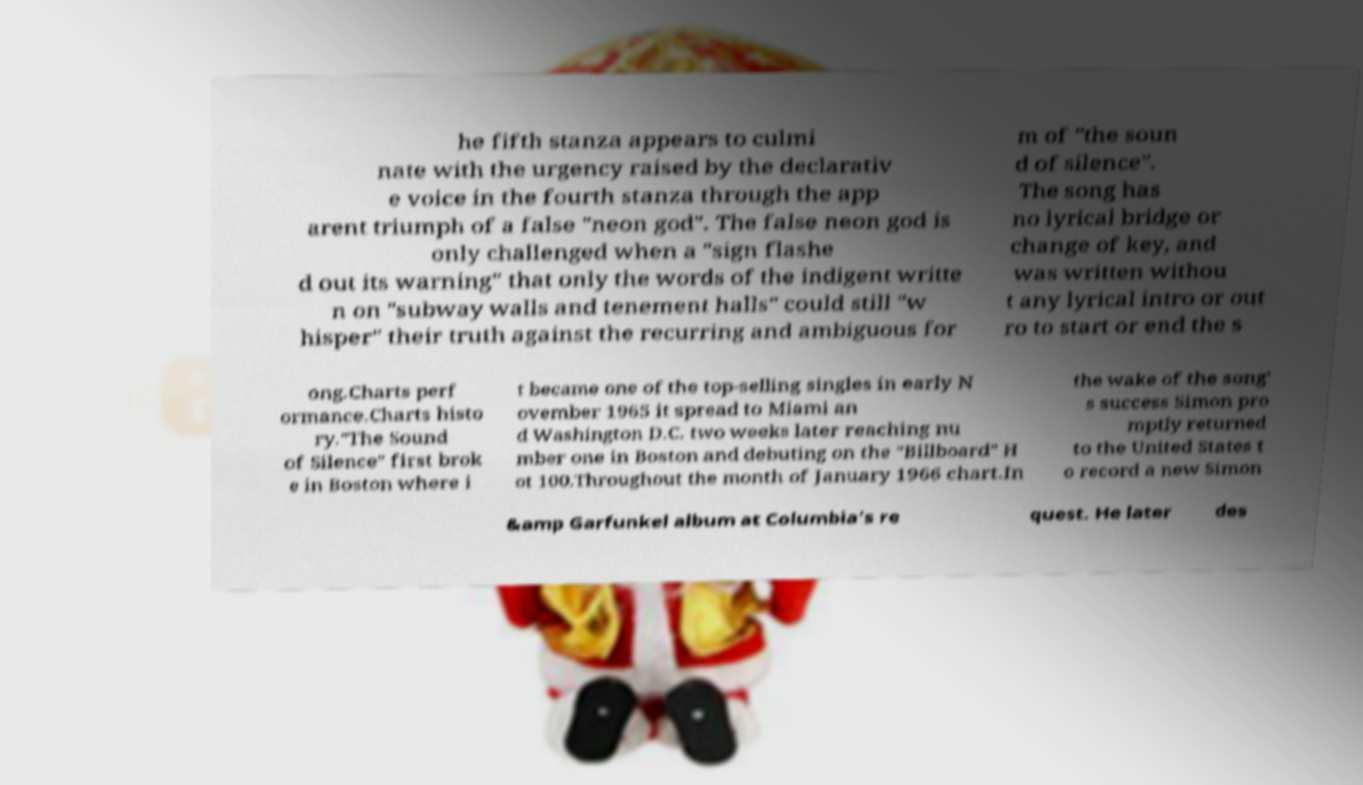What messages or text are displayed in this image? I need them in a readable, typed format. he fifth stanza appears to culmi nate with the urgency raised by the declarativ e voice in the fourth stanza through the app arent triumph of a false "neon god". The false neon god is only challenged when a "sign flashe d out its warning" that only the words of the indigent writte n on "subway walls and tenement halls" could still "w hisper" their truth against the recurring and ambiguous for m of "the soun d of silence". The song has no lyrical bridge or change of key, and was written withou t any lyrical intro or out ro to start or end the s ong.Charts perf ormance.Charts histo ry."The Sound of Silence" first brok e in Boston where i t became one of the top-selling singles in early N ovember 1965 it spread to Miami an d Washington D.C. two weeks later reaching nu mber one in Boston and debuting on the "Billboard" H ot 100.Throughout the month of January 1966 chart.In the wake of the song' s success Simon pro mptly returned to the United States t o record a new Simon &amp Garfunkel album at Columbia's re quest. He later des 